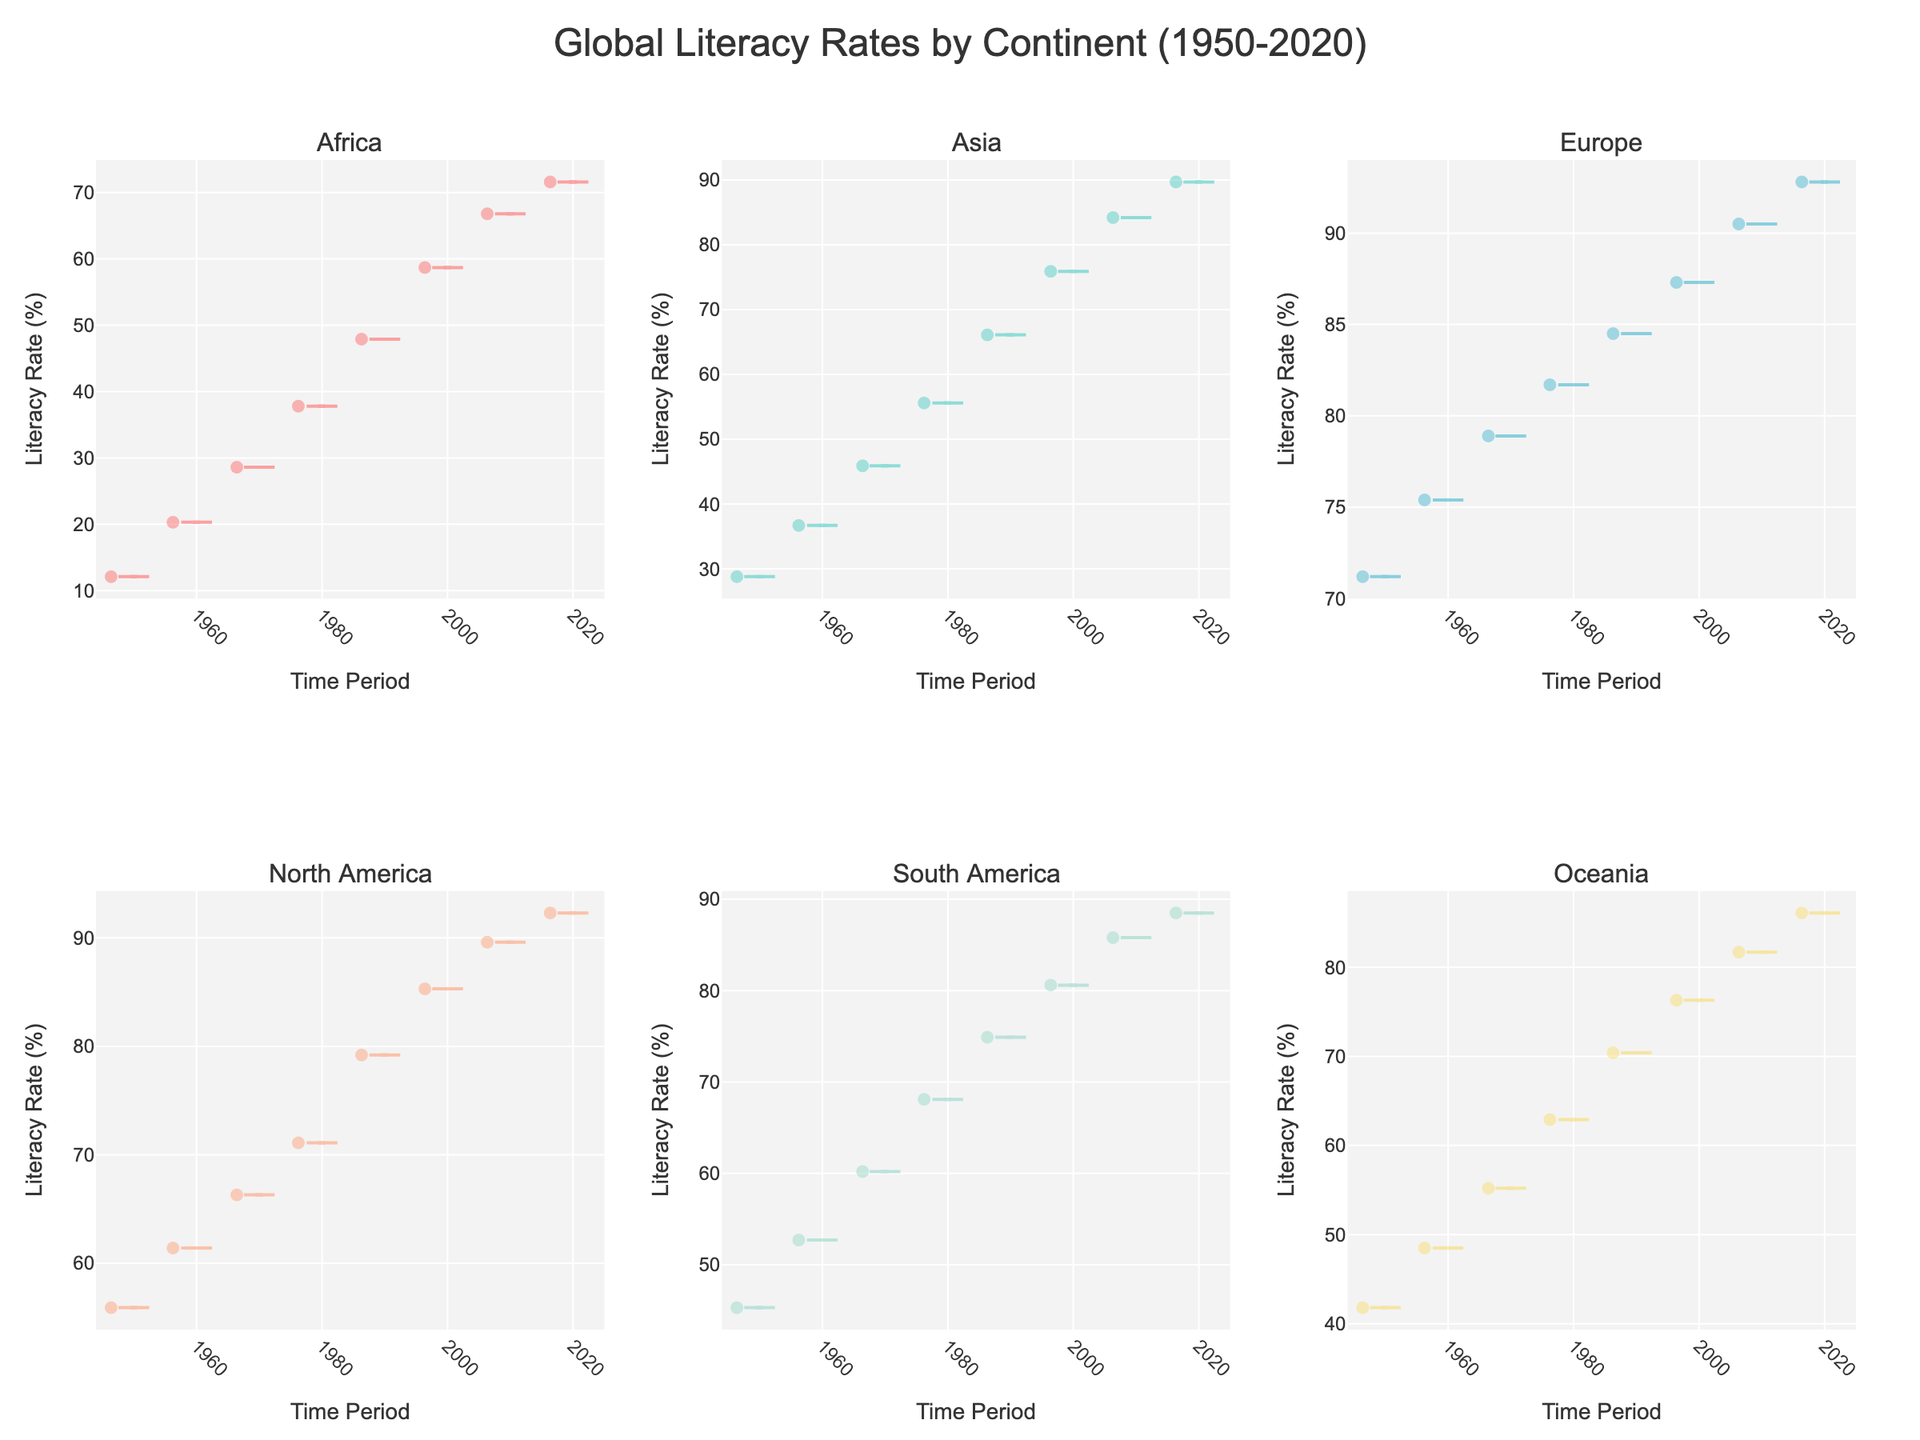What is the title of the figure? The title of the figure is displayed at the top of the image and is aligned in the center. It should be readable and prominent.
Answer: Global Literacy Rates by Continent (1950-2020) What is the range of literacy rates depicted for Africa? The violin plot for Africa shows the distribution of literacy rates over time. The range can be observed from the minimum to maximum points in the plot.
Answer: 12.1% to 71.6% Which continent shows the highest literacy rate in the plot? By observing the upper ends of the violin plots for each continent, Europe has the highest literacy rate.
Answer: Europe How does the literacy rate in Asia change from 1950 to 2020? The violin plot for Asia expands from 1950 to 2020. By observing the spread of data points across these years, the literacy rate increases gradually.
Answer: 28.8% to 89.7% In the 1980s, which continent had the highest literacy rate, and what was it? By looking at the data points around 1980 in each violin plot, Europe had the highest literacy rate during this period.
Answer: Europe, 81.7% Which continent experienced the largest increase in literacy rate from 1950 to 2020? By comparing the ranges in each plot from 1950 to 2020, both visually and by calculated increases, Africa experienced the largest increase.
Answer: Africa How are the literacy rates distributed in South America between 1950 and 2020? The distribution of literacy rates in South America can be observed through the shape and spread of the South American violin plot. It shows a progression to higher literacy rates over time.
Answer: 45.3% to 88.5% What is significant about the literacy rates in Oceania from 1950 to 2020? Observing the change in the plot for Oceania, it shows improvement over time, with literacy rates steadily climbing.
Answer: 41.8% to 86.1% Comparatively, which continent had a more stabilized increase in literacy rates over time, Europe or North America? By analyzing the smoothness and consistency in the upward trend of the violin plots, Europe shows a more stabilized and steady increase in literacy rates.
Answer: Europe 